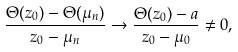<formula> <loc_0><loc_0><loc_500><loc_500>\frac { \Theta ( z _ { 0 } ) - \Theta ( \mu _ { n } ) } { z _ { 0 } - \mu _ { n } } \to \frac { \Theta ( z _ { 0 } ) - a } { z _ { 0 } - \mu _ { 0 } } \not = 0 ,</formula> 